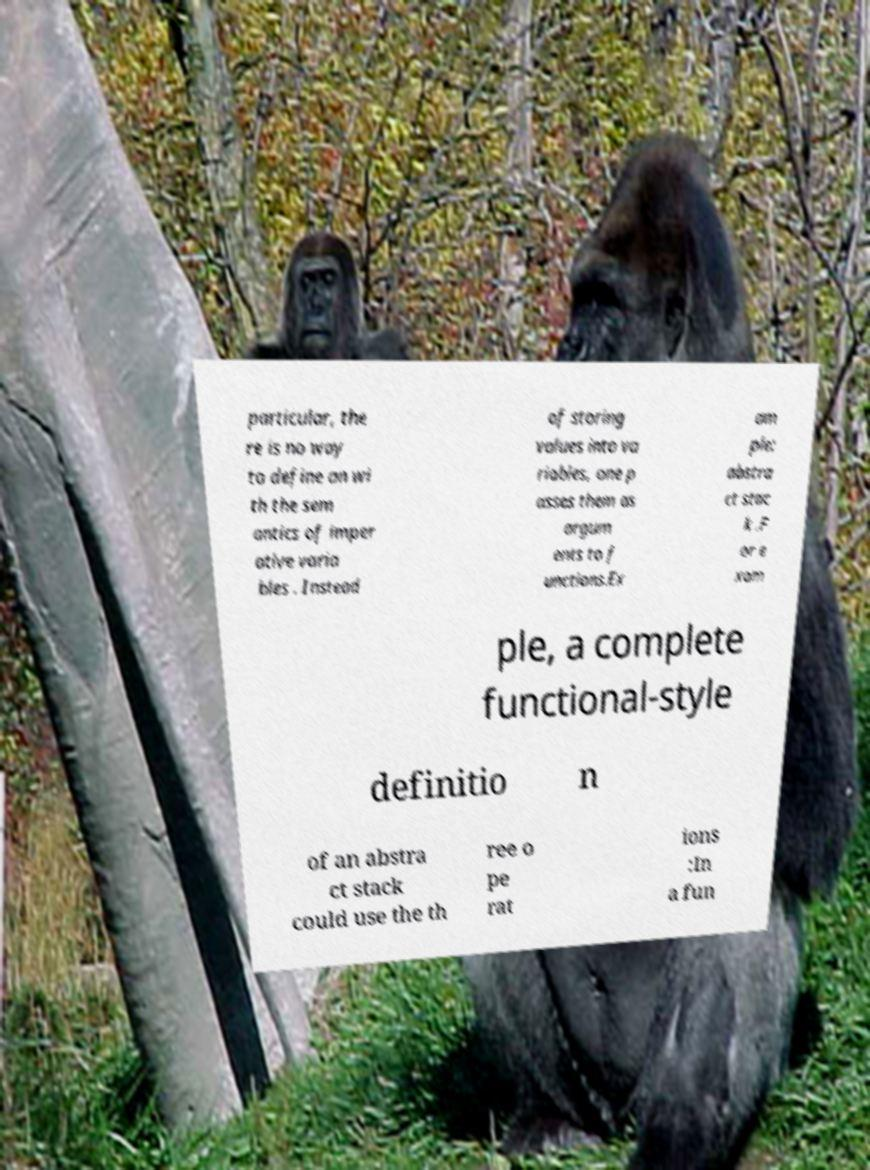Can you read and provide the text displayed in the image?This photo seems to have some interesting text. Can you extract and type it out for me? particular, the re is no way to define an wi th the sem antics of imper ative varia bles . Instead of storing values into va riables, one p asses them as argum ents to f unctions.Ex am ple: abstra ct stac k .F or e xam ple, a complete functional-style definitio n of an abstra ct stack could use the th ree o pe rat ions :In a fun 